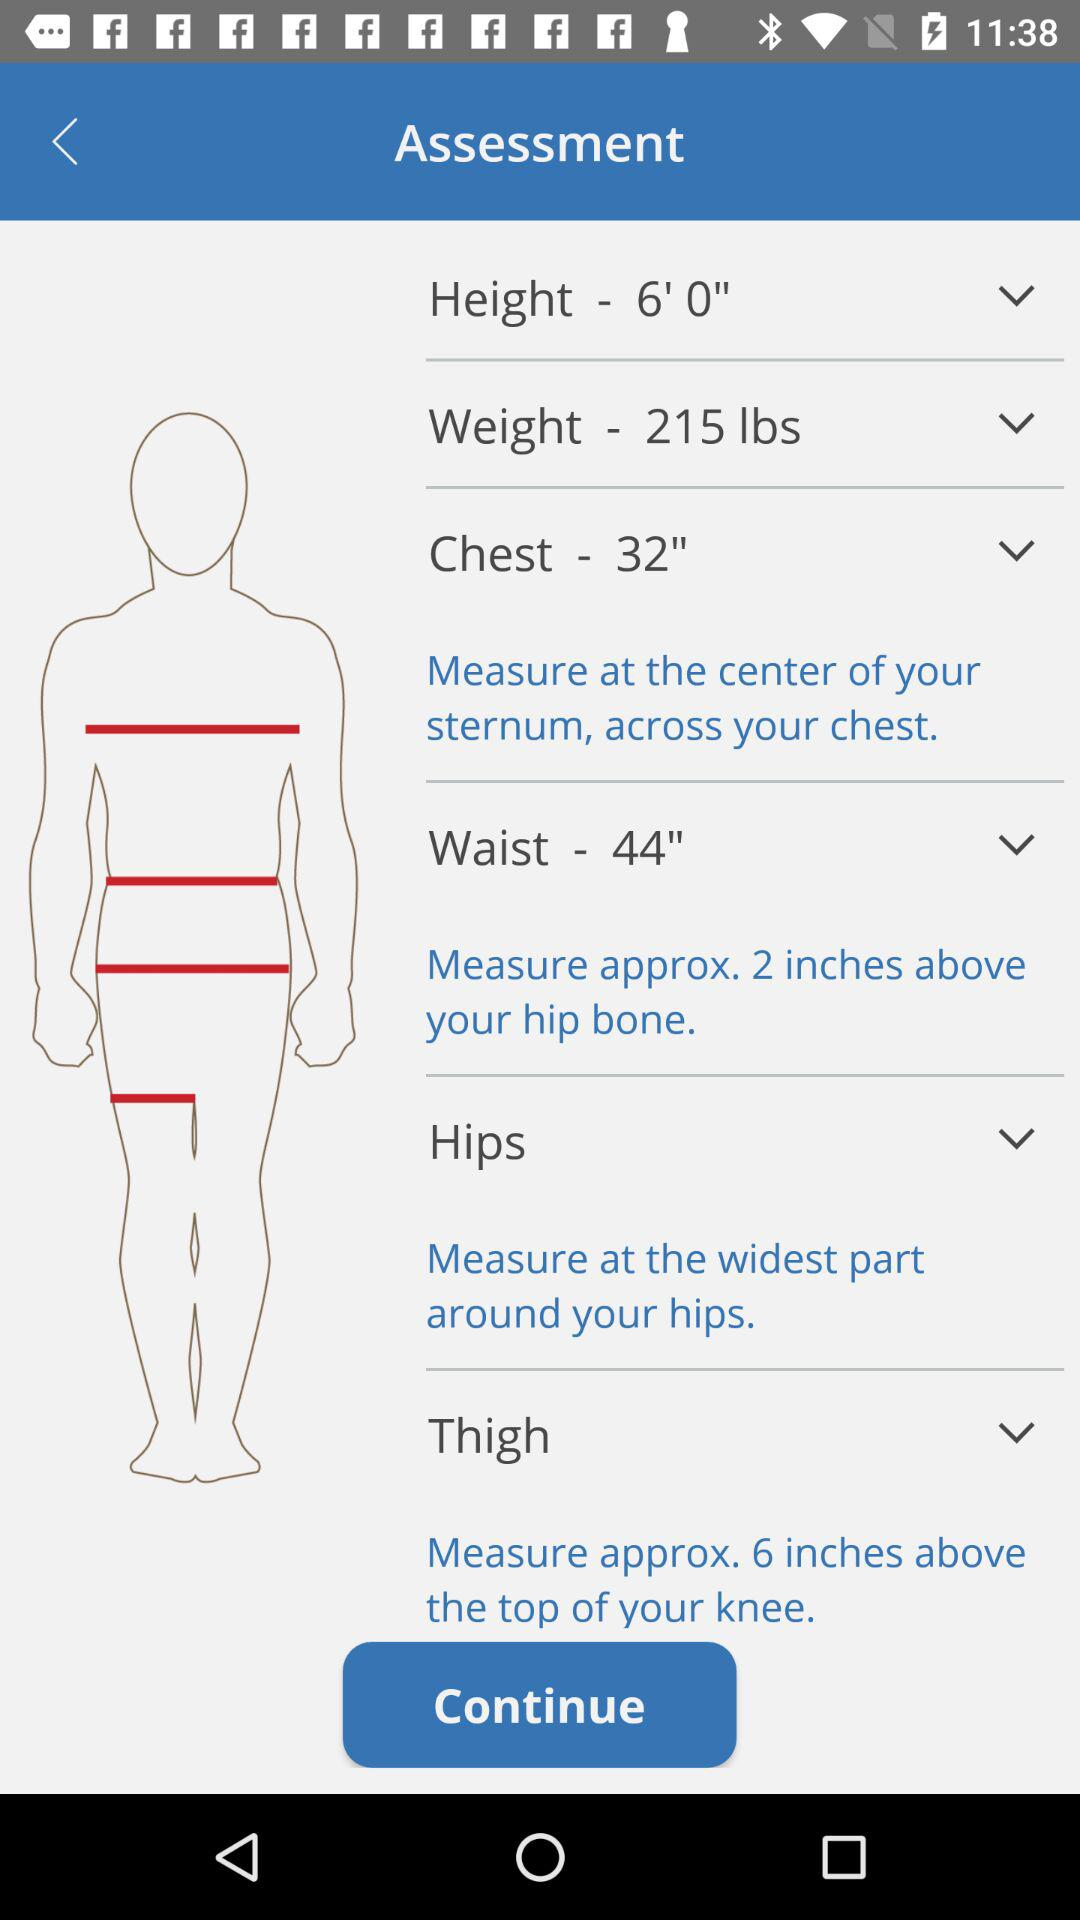What is the instruction given to measure the chest? The instruction given to measure the chest is "Measure at the center of your sternum, across your chest". 